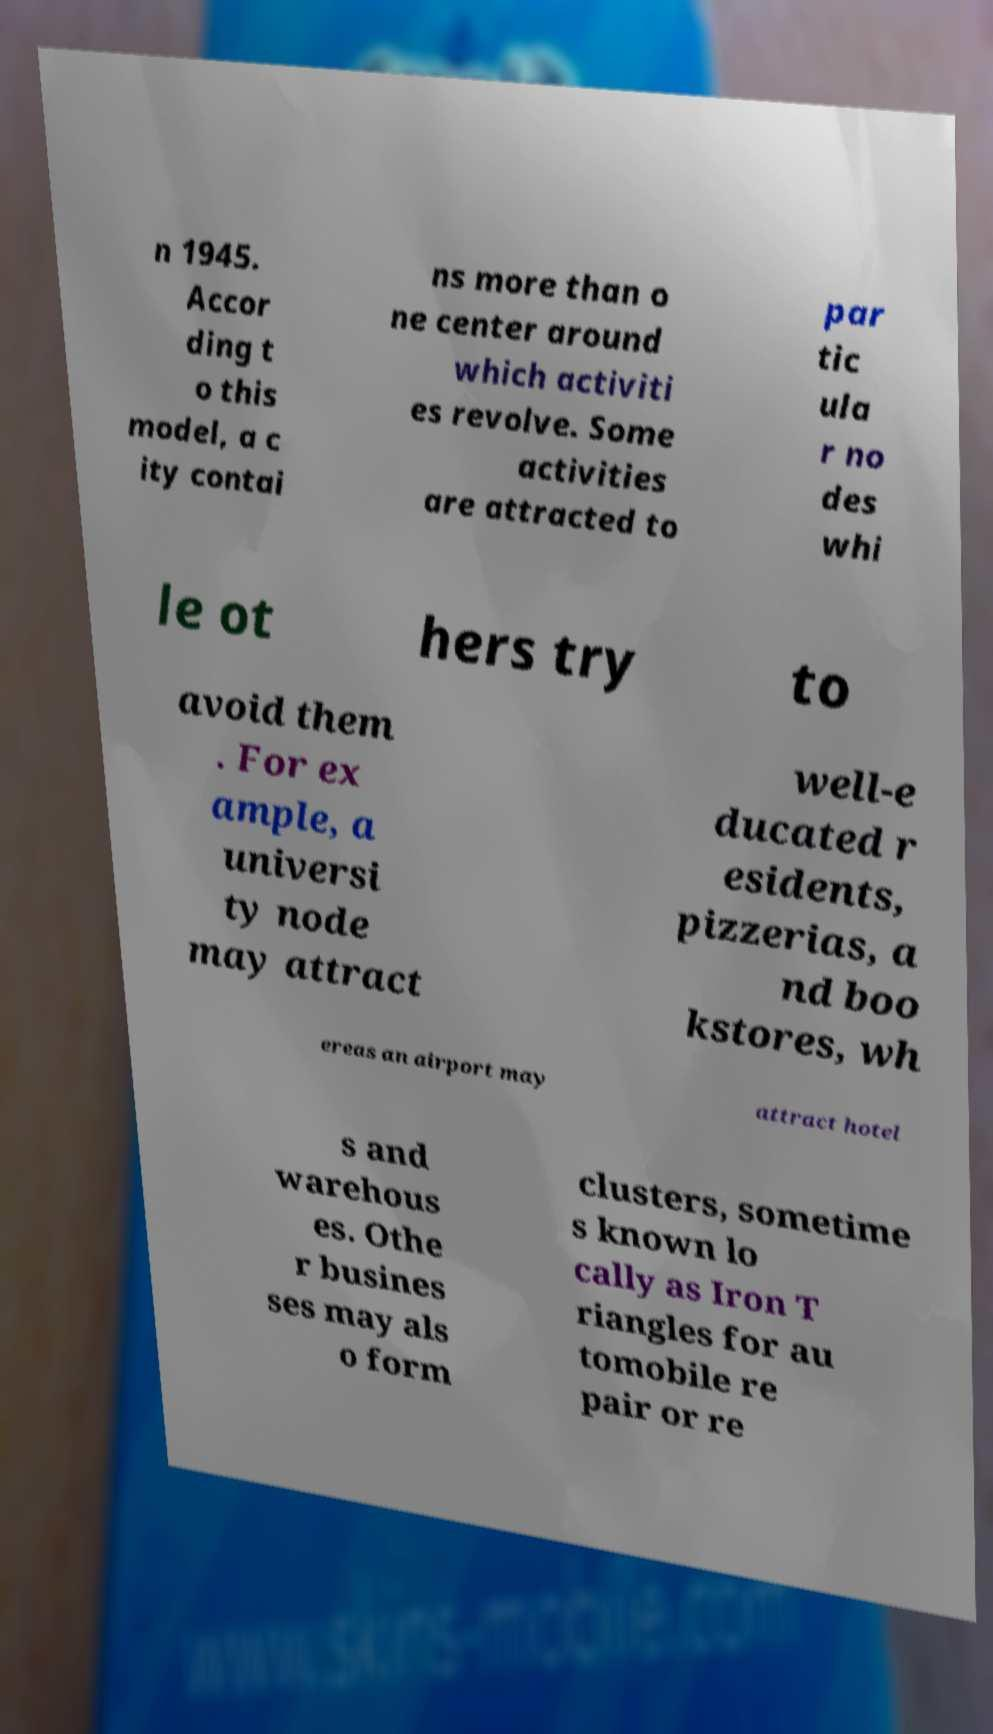Can you read and provide the text displayed in the image?This photo seems to have some interesting text. Can you extract and type it out for me? n 1945. Accor ding t o this model, a c ity contai ns more than o ne center around which activiti es revolve. Some activities are attracted to par tic ula r no des whi le ot hers try to avoid them . For ex ample, a universi ty node may attract well-e ducated r esidents, pizzerias, a nd boo kstores, wh ereas an airport may attract hotel s and warehous es. Othe r busines ses may als o form clusters, sometime s known lo cally as Iron T riangles for au tomobile re pair or re 